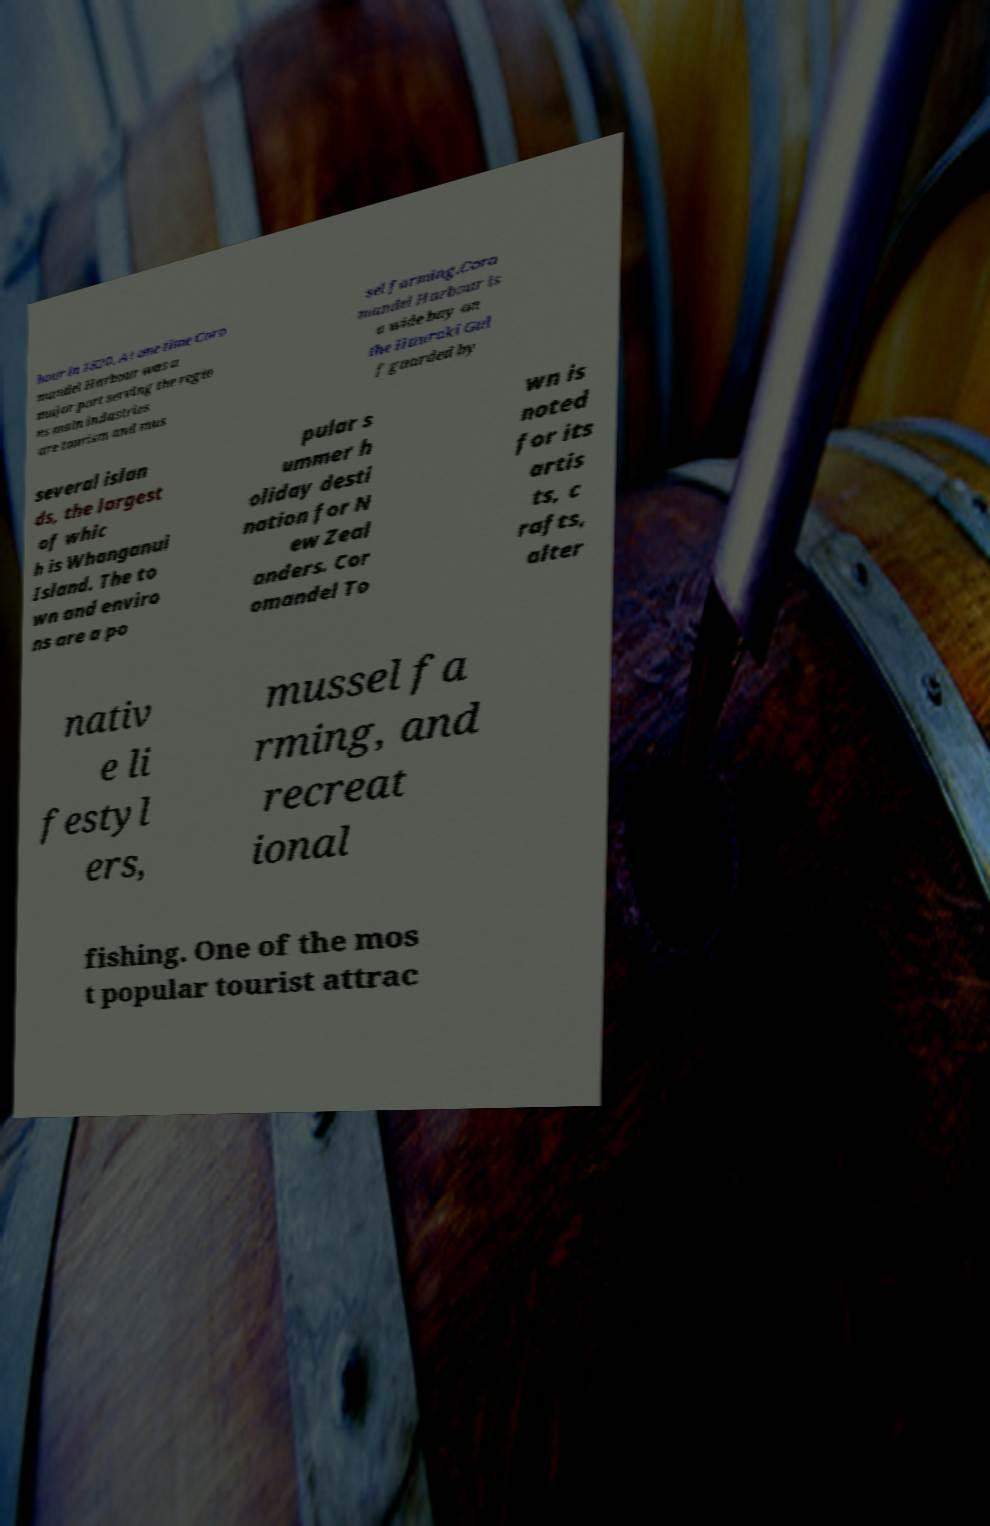Could you assist in decoding the text presented in this image and type it out clearly? bour in 1820. At one time Coro mandel Harbour was a major port serving the regio ns main industries are tourism and mus sel farming.Coro mandel Harbour is a wide bay on the Hauraki Gul f guarded by several islan ds, the largest of whic h is Whanganui Island. The to wn and enviro ns are a po pular s ummer h oliday desti nation for N ew Zeal anders. Cor omandel To wn is noted for its artis ts, c rafts, alter nativ e li festyl ers, mussel fa rming, and recreat ional fishing. One of the mos t popular tourist attrac 